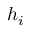Convert formula to latex. <formula><loc_0><loc_0><loc_500><loc_500>h _ { i }</formula> 